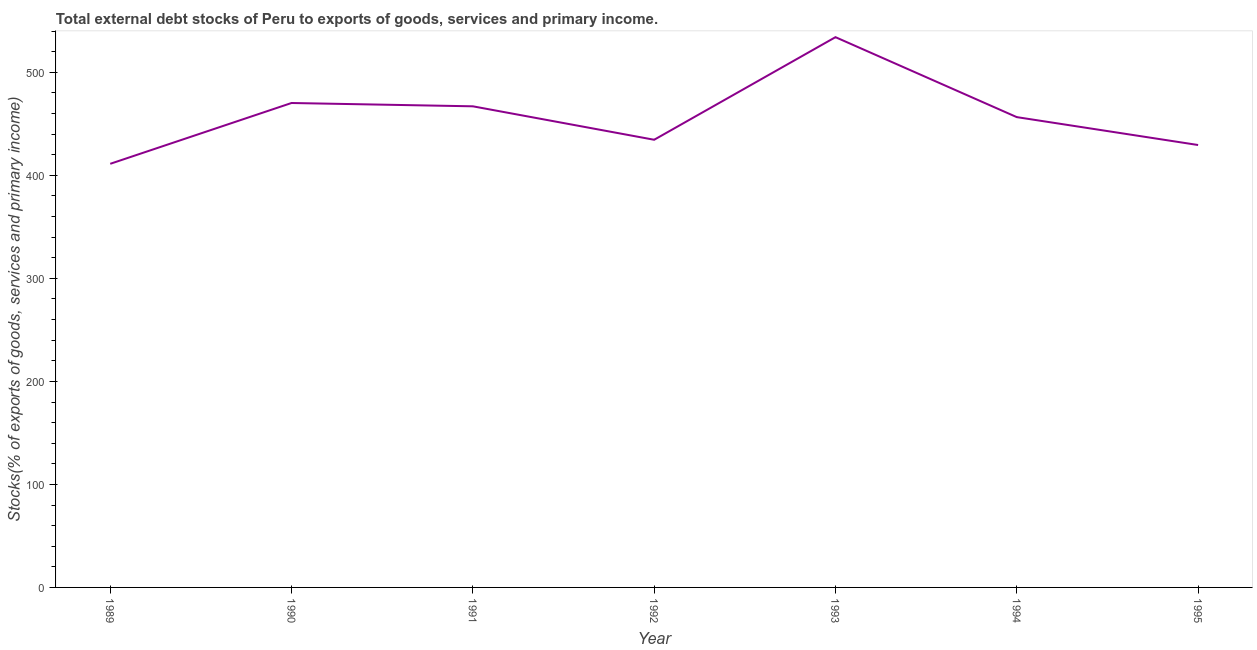What is the external debt stocks in 1989?
Provide a short and direct response. 411.25. Across all years, what is the maximum external debt stocks?
Offer a very short reply. 534.19. Across all years, what is the minimum external debt stocks?
Provide a succinct answer. 411.25. In which year was the external debt stocks maximum?
Your answer should be compact. 1993. What is the sum of the external debt stocks?
Your answer should be very brief. 3203.4. What is the difference between the external debt stocks in 1990 and 1991?
Provide a succinct answer. 3.22. What is the average external debt stocks per year?
Make the answer very short. 457.63. What is the median external debt stocks?
Provide a short and direct response. 456.56. What is the ratio of the external debt stocks in 1989 to that in 1993?
Offer a terse response. 0.77. What is the difference between the highest and the second highest external debt stocks?
Keep it short and to the point. 63.91. What is the difference between the highest and the lowest external debt stocks?
Offer a terse response. 122.94. How many lines are there?
Offer a terse response. 1. How many years are there in the graph?
Give a very brief answer. 7. What is the title of the graph?
Offer a terse response. Total external debt stocks of Peru to exports of goods, services and primary income. What is the label or title of the X-axis?
Provide a succinct answer. Year. What is the label or title of the Y-axis?
Make the answer very short. Stocks(% of exports of goods, services and primary income). What is the Stocks(% of exports of goods, services and primary income) in 1989?
Offer a terse response. 411.25. What is the Stocks(% of exports of goods, services and primary income) in 1990?
Your answer should be compact. 470.28. What is the Stocks(% of exports of goods, services and primary income) of 1991?
Make the answer very short. 467.06. What is the Stocks(% of exports of goods, services and primary income) in 1992?
Offer a terse response. 434.58. What is the Stocks(% of exports of goods, services and primary income) of 1993?
Provide a short and direct response. 534.19. What is the Stocks(% of exports of goods, services and primary income) in 1994?
Ensure brevity in your answer.  456.56. What is the Stocks(% of exports of goods, services and primary income) of 1995?
Offer a very short reply. 429.48. What is the difference between the Stocks(% of exports of goods, services and primary income) in 1989 and 1990?
Provide a succinct answer. -59.03. What is the difference between the Stocks(% of exports of goods, services and primary income) in 1989 and 1991?
Provide a succinct answer. -55.81. What is the difference between the Stocks(% of exports of goods, services and primary income) in 1989 and 1992?
Offer a terse response. -23.34. What is the difference between the Stocks(% of exports of goods, services and primary income) in 1989 and 1993?
Make the answer very short. -122.94. What is the difference between the Stocks(% of exports of goods, services and primary income) in 1989 and 1994?
Provide a succinct answer. -45.31. What is the difference between the Stocks(% of exports of goods, services and primary income) in 1989 and 1995?
Provide a short and direct response. -18.24. What is the difference between the Stocks(% of exports of goods, services and primary income) in 1990 and 1991?
Ensure brevity in your answer.  3.22. What is the difference between the Stocks(% of exports of goods, services and primary income) in 1990 and 1992?
Keep it short and to the point. 35.69. What is the difference between the Stocks(% of exports of goods, services and primary income) in 1990 and 1993?
Give a very brief answer. -63.91. What is the difference between the Stocks(% of exports of goods, services and primary income) in 1990 and 1994?
Your answer should be compact. 13.72. What is the difference between the Stocks(% of exports of goods, services and primary income) in 1990 and 1995?
Provide a succinct answer. 40.79. What is the difference between the Stocks(% of exports of goods, services and primary income) in 1991 and 1992?
Your answer should be very brief. 32.48. What is the difference between the Stocks(% of exports of goods, services and primary income) in 1991 and 1993?
Offer a terse response. -67.13. What is the difference between the Stocks(% of exports of goods, services and primary income) in 1991 and 1994?
Your response must be concise. 10.51. What is the difference between the Stocks(% of exports of goods, services and primary income) in 1991 and 1995?
Give a very brief answer. 37.58. What is the difference between the Stocks(% of exports of goods, services and primary income) in 1992 and 1993?
Provide a succinct answer. -99.61. What is the difference between the Stocks(% of exports of goods, services and primary income) in 1992 and 1994?
Your answer should be compact. -21.97. What is the difference between the Stocks(% of exports of goods, services and primary income) in 1992 and 1995?
Give a very brief answer. 5.1. What is the difference between the Stocks(% of exports of goods, services and primary income) in 1993 and 1994?
Give a very brief answer. 77.63. What is the difference between the Stocks(% of exports of goods, services and primary income) in 1993 and 1995?
Your response must be concise. 104.71. What is the difference between the Stocks(% of exports of goods, services and primary income) in 1994 and 1995?
Make the answer very short. 27.07. What is the ratio of the Stocks(% of exports of goods, services and primary income) in 1989 to that in 1990?
Make the answer very short. 0.87. What is the ratio of the Stocks(% of exports of goods, services and primary income) in 1989 to that in 1991?
Offer a terse response. 0.88. What is the ratio of the Stocks(% of exports of goods, services and primary income) in 1989 to that in 1992?
Offer a terse response. 0.95. What is the ratio of the Stocks(% of exports of goods, services and primary income) in 1989 to that in 1993?
Give a very brief answer. 0.77. What is the ratio of the Stocks(% of exports of goods, services and primary income) in 1989 to that in 1994?
Give a very brief answer. 0.9. What is the ratio of the Stocks(% of exports of goods, services and primary income) in 1989 to that in 1995?
Your answer should be compact. 0.96. What is the ratio of the Stocks(% of exports of goods, services and primary income) in 1990 to that in 1991?
Make the answer very short. 1.01. What is the ratio of the Stocks(% of exports of goods, services and primary income) in 1990 to that in 1992?
Offer a terse response. 1.08. What is the ratio of the Stocks(% of exports of goods, services and primary income) in 1990 to that in 1994?
Your response must be concise. 1.03. What is the ratio of the Stocks(% of exports of goods, services and primary income) in 1990 to that in 1995?
Provide a succinct answer. 1.09. What is the ratio of the Stocks(% of exports of goods, services and primary income) in 1991 to that in 1992?
Make the answer very short. 1.07. What is the ratio of the Stocks(% of exports of goods, services and primary income) in 1991 to that in 1993?
Provide a succinct answer. 0.87. What is the ratio of the Stocks(% of exports of goods, services and primary income) in 1991 to that in 1995?
Your answer should be compact. 1.09. What is the ratio of the Stocks(% of exports of goods, services and primary income) in 1992 to that in 1993?
Your response must be concise. 0.81. What is the ratio of the Stocks(% of exports of goods, services and primary income) in 1992 to that in 1994?
Provide a succinct answer. 0.95. What is the ratio of the Stocks(% of exports of goods, services and primary income) in 1993 to that in 1994?
Offer a very short reply. 1.17. What is the ratio of the Stocks(% of exports of goods, services and primary income) in 1993 to that in 1995?
Your response must be concise. 1.24. What is the ratio of the Stocks(% of exports of goods, services and primary income) in 1994 to that in 1995?
Your answer should be compact. 1.06. 